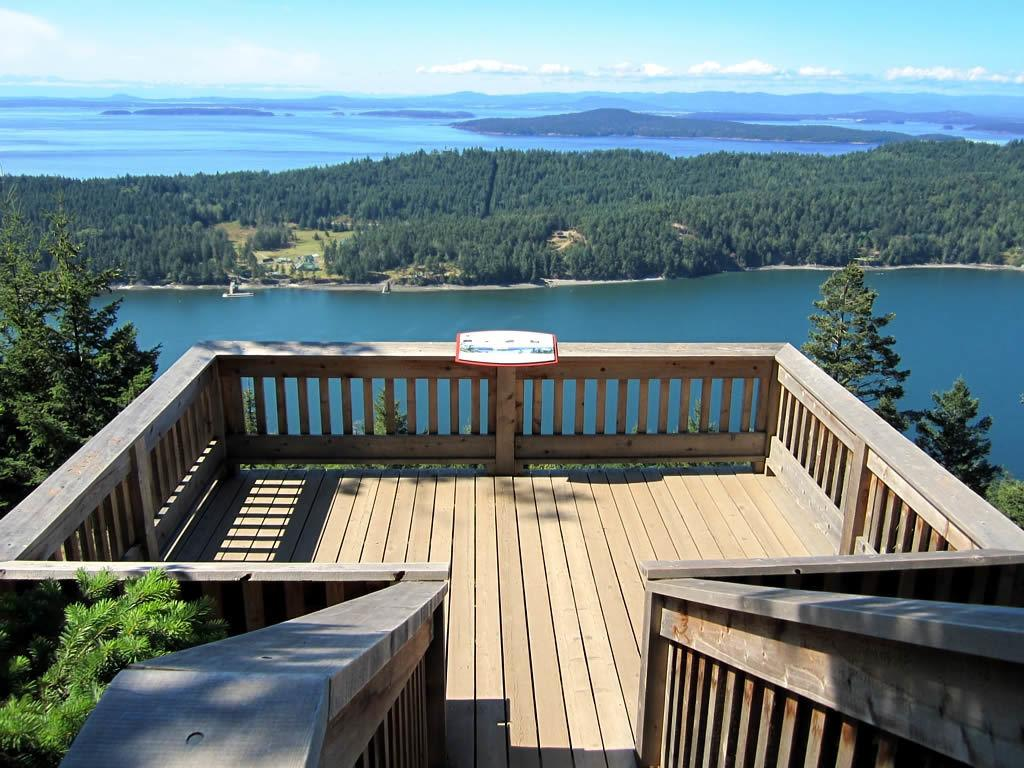What type of vegetation can be seen in the image? There are trees in the image. What natural element is visible in the image? There is water visible in the image. What part of the natural environment is visible in the image? The sky is visible in the image. What type of structure is present in the image? There is a wooden balcony in the image. Can you see a bee buzzing around the trees in the image? There is no bee visible in the image; it only features trees, water, sky, and a wooden balcony. Is there a crook standing on the wooden balcony in the image? There is no crook present in the image; it only features trees, water, sky, and a wooden balcony. 